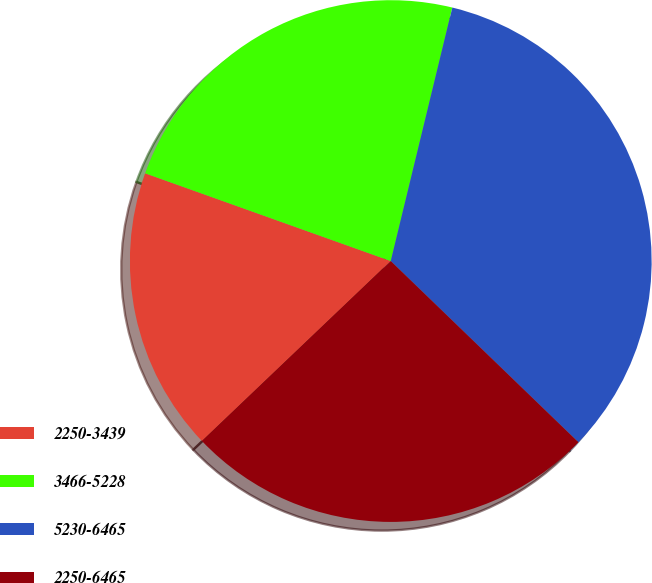Convert chart. <chart><loc_0><loc_0><loc_500><loc_500><pie_chart><fcel>2250-3439<fcel>3466-5228<fcel>5230-6465<fcel>2250-6465<nl><fcel>17.58%<fcel>23.33%<fcel>33.43%<fcel>25.66%<nl></chart> 